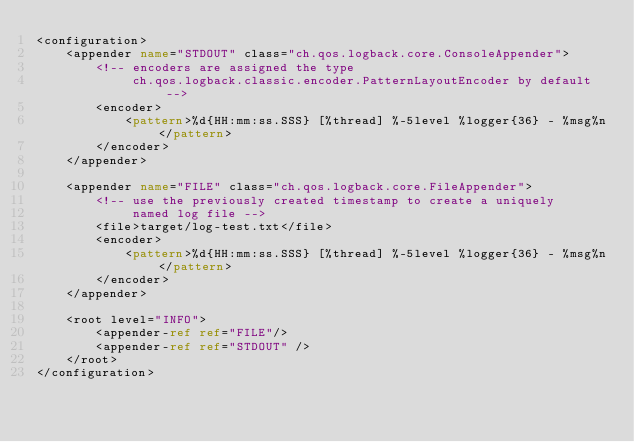Convert code to text. <code><loc_0><loc_0><loc_500><loc_500><_XML_><configuration>
    <appender name="STDOUT" class="ch.qos.logback.core.ConsoleAppender">
        <!-- encoders are assigned the type
             ch.qos.logback.classic.encoder.PatternLayoutEncoder by default -->
        <encoder>
            <pattern>%d{HH:mm:ss.SSS} [%thread] %-5level %logger{36} - %msg%n</pattern>
        </encoder>
    </appender>

    <appender name="FILE" class="ch.qos.logback.core.FileAppender">
        <!-- use the previously created timestamp to create a uniquely
             named log file -->
        <file>target/log-test.txt</file>
        <encoder>
            <pattern>%d{HH:mm:ss.SSS} [%thread] %-5level %logger{36} - %msg%n</pattern>
        </encoder>
    </appender>

    <root level="INFO">
        <appender-ref ref="FILE"/>
        <appender-ref ref="STDOUT" />
    </root>
</configuration></code> 